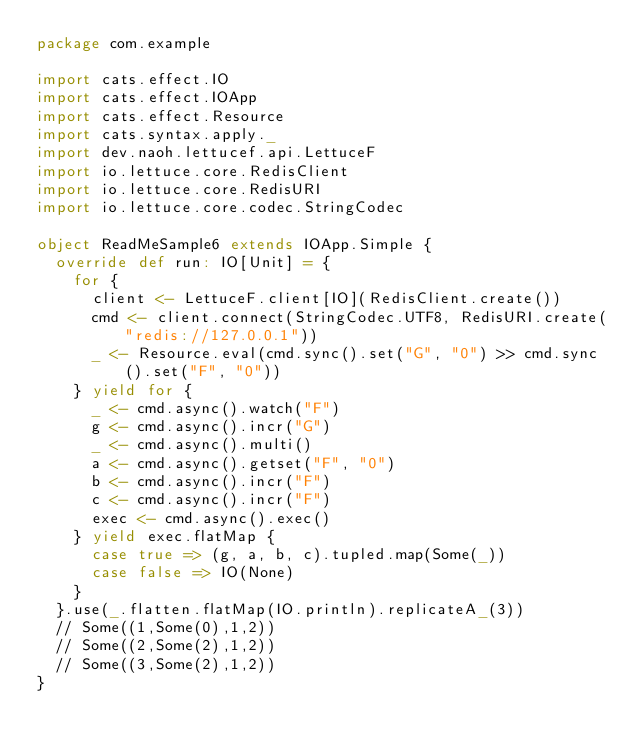Convert code to text. <code><loc_0><loc_0><loc_500><loc_500><_Scala_>package com.example

import cats.effect.IO
import cats.effect.IOApp
import cats.effect.Resource
import cats.syntax.apply._
import dev.naoh.lettucef.api.LettuceF
import io.lettuce.core.RedisClient
import io.lettuce.core.RedisURI
import io.lettuce.core.codec.StringCodec

object ReadMeSample6 extends IOApp.Simple {
  override def run: IO[Unit] = {
    for {
      client <- LettuceF.client[IO](RedisClient.create())
      cmd <- client.connect(StringCodec.UTF8, RedisURI.create("redis://127.0.0.1"))
      _ <- Resource.eval(cmd.sync().set("G", "0") >> cmd.sync().set("F", "0"))
    } yield for {
      _ <- cmd.async().watch("F")
      g <- cmd.async().incr("G")
      _ <- cmd.async().multi()
      a <- cmd.async().getset("F", "0")
      b <- cmd.async().incr("F")
      c <- cmd.async().incr("F")
      exec <- cmd.async().exec()
    } yield exec.flatMap {
      case true => (g, a, b, c).tupled.map(Some(_))
      case false => IO(None)
    }
  }.use(_.flatten.flatMap(IO.println).replicateA_(3))
  // Some((1,Some(0),1,2))
  // Some((2,Some(2),1,2))
  // Some((3,Some(2),1,2))
}
</code> 